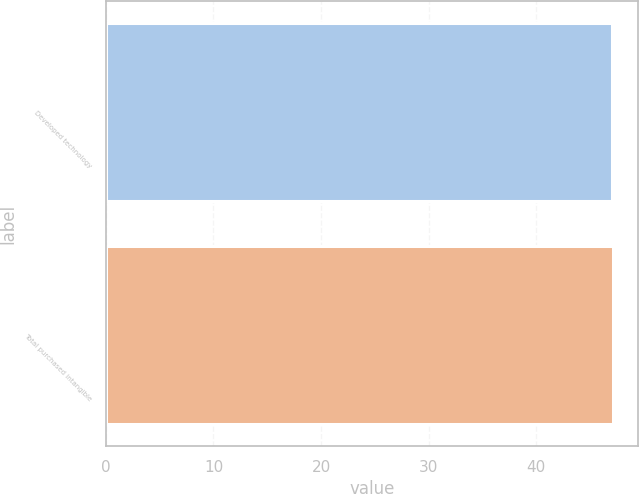<chart> <loc_0><loc_0><loc_500><loc_500><bar_chart><fcel>Developed technology<fcel>Total purchased intangible<nl><fcel>47<fcel>47.1<nl></chart> 